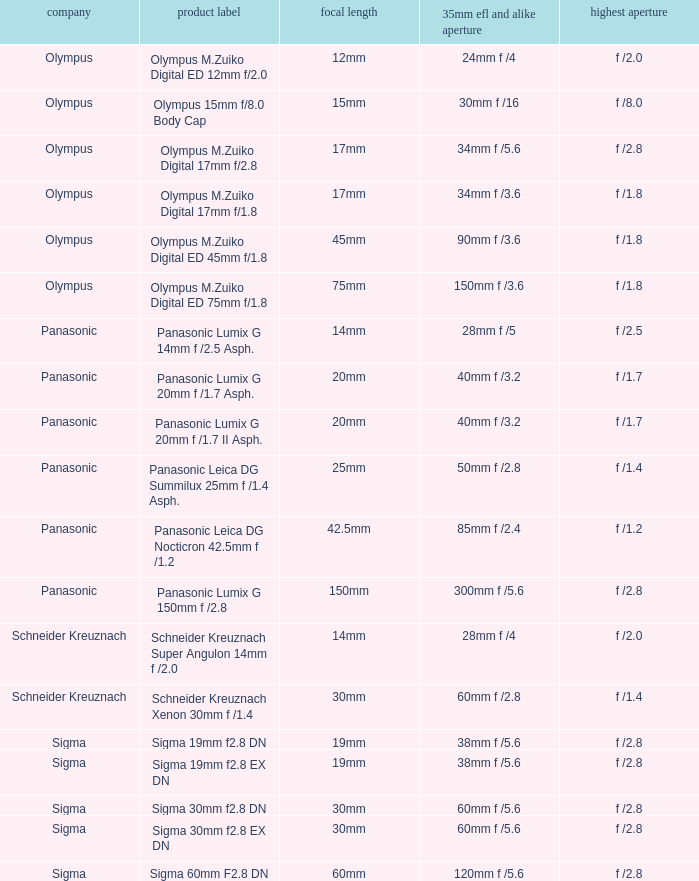What is the maximum aperture of the lens(es) with a focal length of 20mm? F /1.7, f /1.7. 